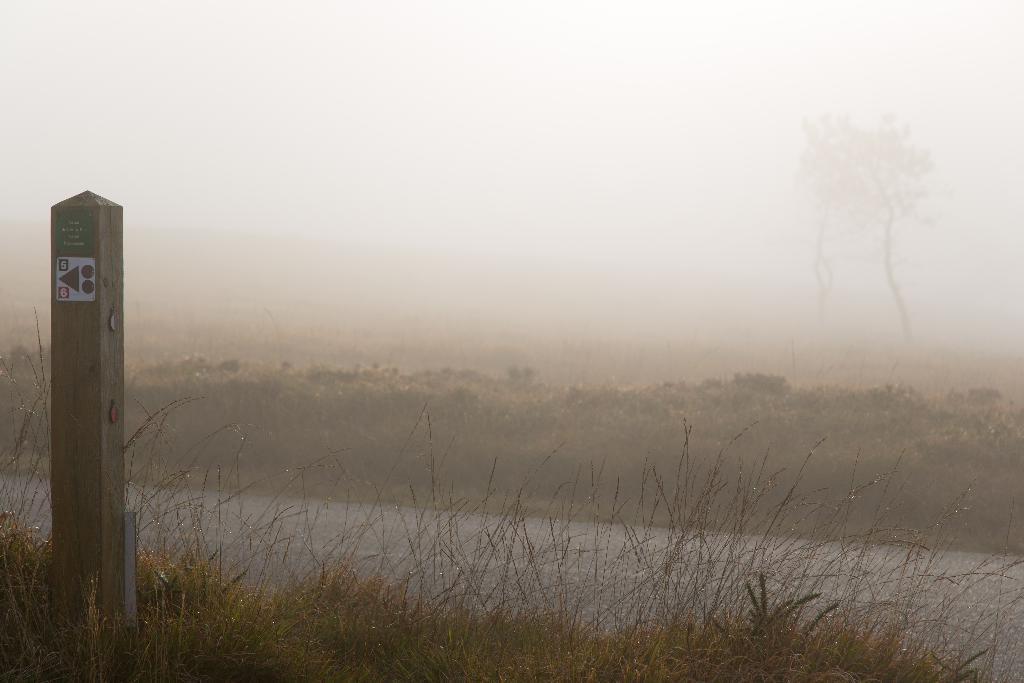Please provide a concise description of this image. This picture might be taken from outside of the city. In this image, on the left side, we can see a wood pole. In the background there are some trees. On the top, we can see a sky, at the bottom there a is a road and a grass. 